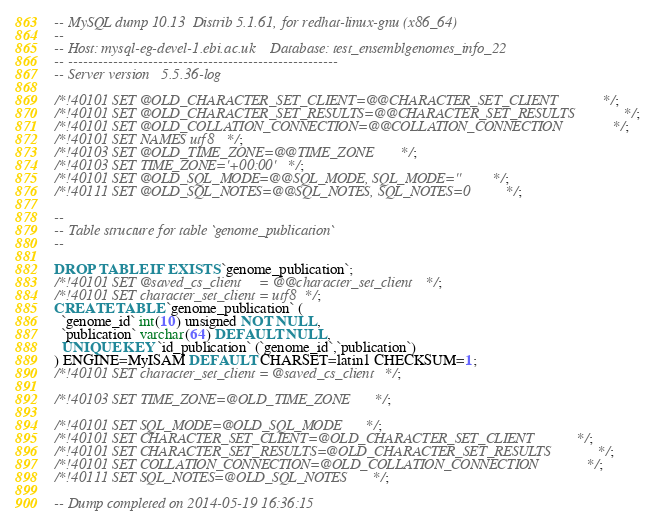<code> <loc_0><loc_0><loc_500><loc_500><_SQL_>-- MySQL dump 10.13  Distrib 5.1.61, for redhat-linux-gnu (x86_64)
--
-- Host: mysql-eg-devel-1.ebi.ac.uk    Database: test_ensemblgenomes_info_22
-- ------------------------------------------------------
-- Server version	5.5.36-log

/*!40101 SET @OLD_CHARACTER_SET_CLIENT=@@CHARACTER_SET_CLIENT */;
/*!40101 SET @OLD_CHARACTER_SET_RESULTS=@@CHARACTER_SET_RESULTS */;
/*!40101 SET @OLD_COLLATION_CONNECTION=@@COLLATION_CONNECTION */;
/*!40101 SET NAMES utf8 */;
/*!40103 SET @OLD_TIME_ZONE=@@TIME_ZONE */;
/*!40103 SET TIME_ZONE='+00:00' */;
/*!40101 SET @OLD_SQL_MODE=@@SQL_MODE, SQL_MODE='' */;
/*!40111 SET @OLD_SQL_NOTES=@@SQL_NOTES, SQL_NOTES=0 */;

--
-- Table structure for table `genome_publication`
--

DROP TABLE IF EXISTS `genome_publication`;
/*!40101 SET @saved_cs_client     = @@character_set_client */;
/*!40101 SET character_set_client = utf8 */;
CREATE TABLE `genome_publication` (
  `genome_id` int(10) unsigned NOT NULL,
  `publication` varchar(64) DEFAULT NULL,
  UNIQUE KEY `id_publication` (`genome_id`,`publication`)
) ENGINE=MyISAM DEFAULT CHARSET=latin1 CHECKSUM=1;
/*!40101 SET character_set_client = @saved_cs_client */;

/*!40103 SET TIME_ZONE=@OLD_TIME_ZONE */;

/*!40101 SET SQL_MODE=@OLD_SQL_MODE */;
/*!40101 SET CHARACTER_SET_CLIENT=@OLD_CHARACTER_SET_CLIENT */;
/*!40101 SET CHARACTER_SET_RESULTS=@OLD_CHARACTER_SET_RESULTS */;
/*!40101 SET COLLATION_CONNECTION=@OLD_COLLATION_CONNECTION */;
/*!40111 SET SQL_NOTES=@OLD_SQL_NOTES */;

-- Dump completed on 2014-05-19 16:36:15
</code> 